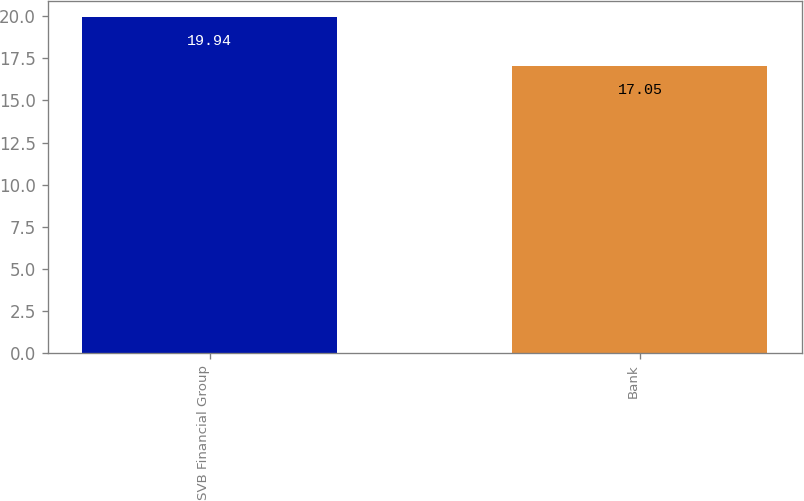Convert chart to OTSL. <chart><loc_0><loc_0><loc_500><loc_500><bar_chart><fcel>SVB Financial Group<fcel>Bank<nl><fcel>19.94<fcel>17.05<nl></chart> 